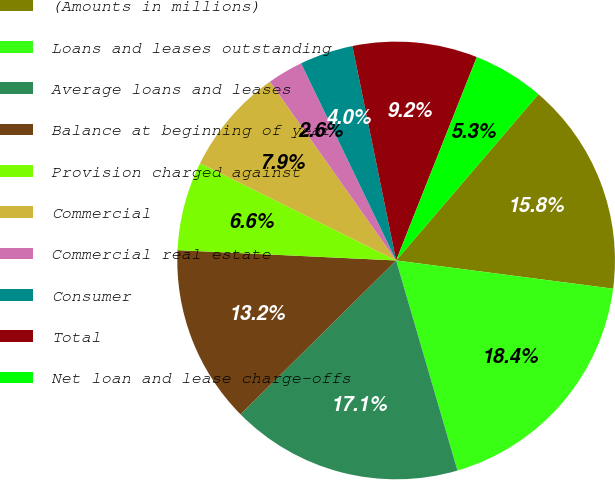<chart> <loc_0><loc_0><loc_500><loc_500><pie_chart><fcel>(Amounts in millions)<fcel>Loans and leases outstanding<fcel>Average loans and leases<fcel>Balance at beginning of year<fcel>Provision charged against<fcel>Commercial<fcel>Commercial real estate<fcel>Consumer<fcel>Total<fcel>Net loan and lease charge-offs<nl><fcel>15.79%<fcel>18.42%<fcel>17.11%<fcel>13.16%<fcel>6.58%<fcel>7.89%<fcel>2.63%<fcel>3.95%<fcel>9.21%<fcel>5.26%<nl></chart> 